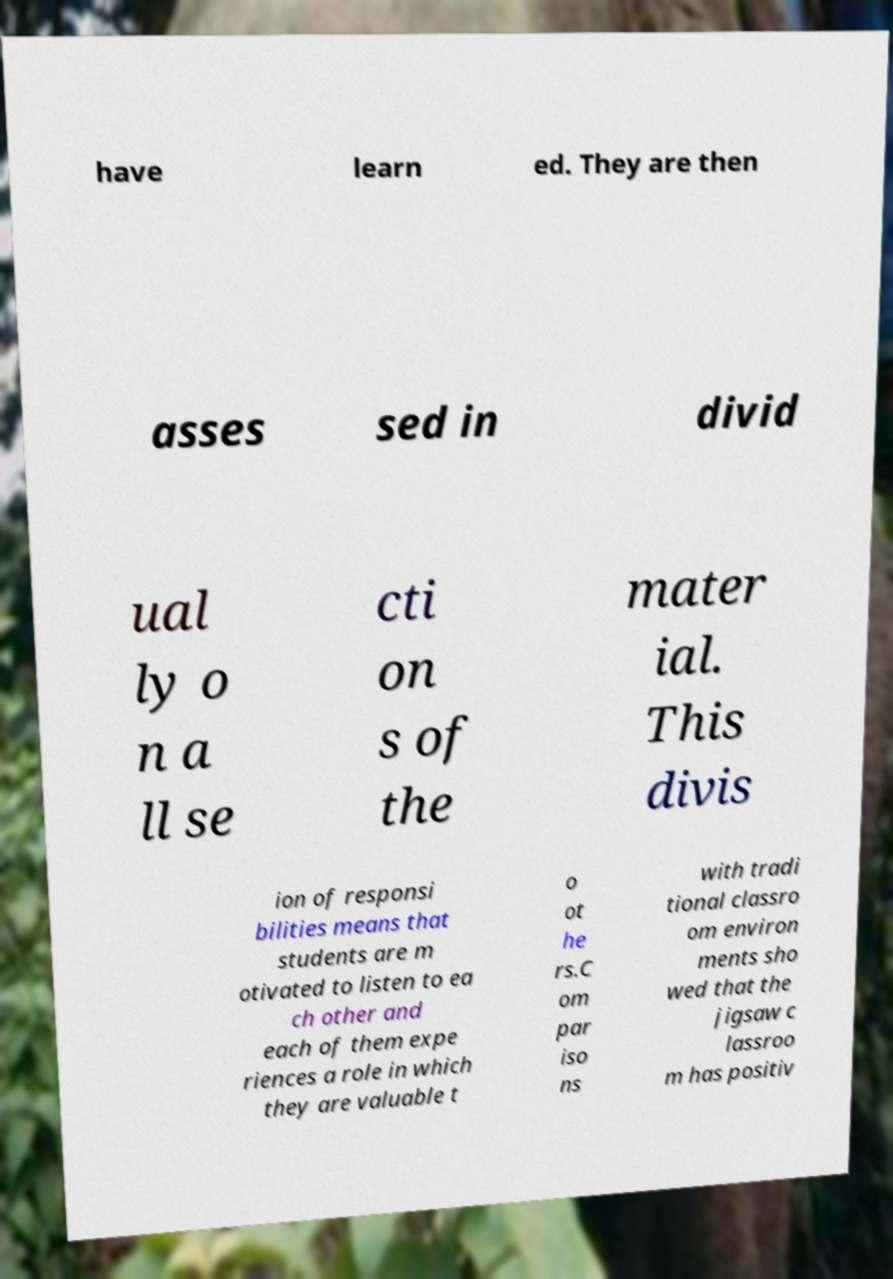I need the written content from this picture converted into text. Can you do that? have learn ed. They are then asses sed in divid ual ly o n a ll se cti on s of the mater ial. This divis ion of responsi bilities means that students are m otivated to listen to ea ch other and each of them expe riences a role in which they are valuable t o ot he rs.C om par iso ns with tradi tional classro om environ ments sho wed that the jigsaw c lassroo m has positiv 